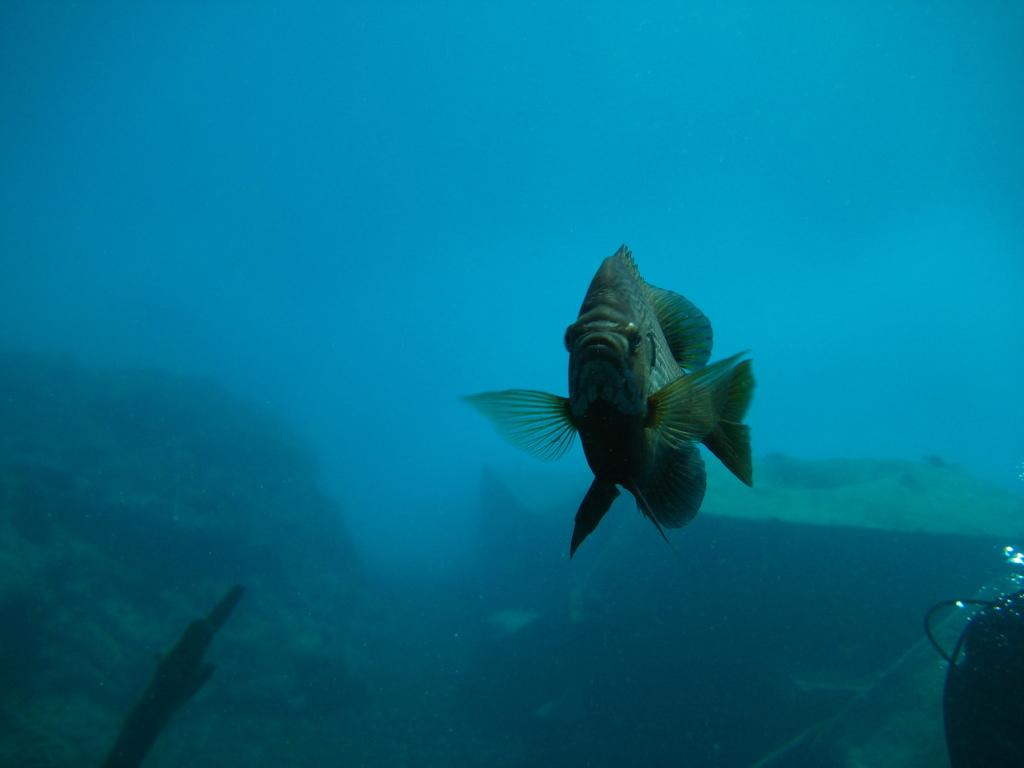What is happening in the water in the image? There is a dip in the water in the image, and there are rocks present. Can you describe the fish in the image? The fish in the image has wings and a tail. What type of health insurance is being advertised on the ship in the image? There is no ship present in the image, and no health insurance is being advertised. Can you tell me how many planes are flying over the fish with wings and a tail in the image? There are no planes present in the image; it only features a fish with wings and a tail in the water. 